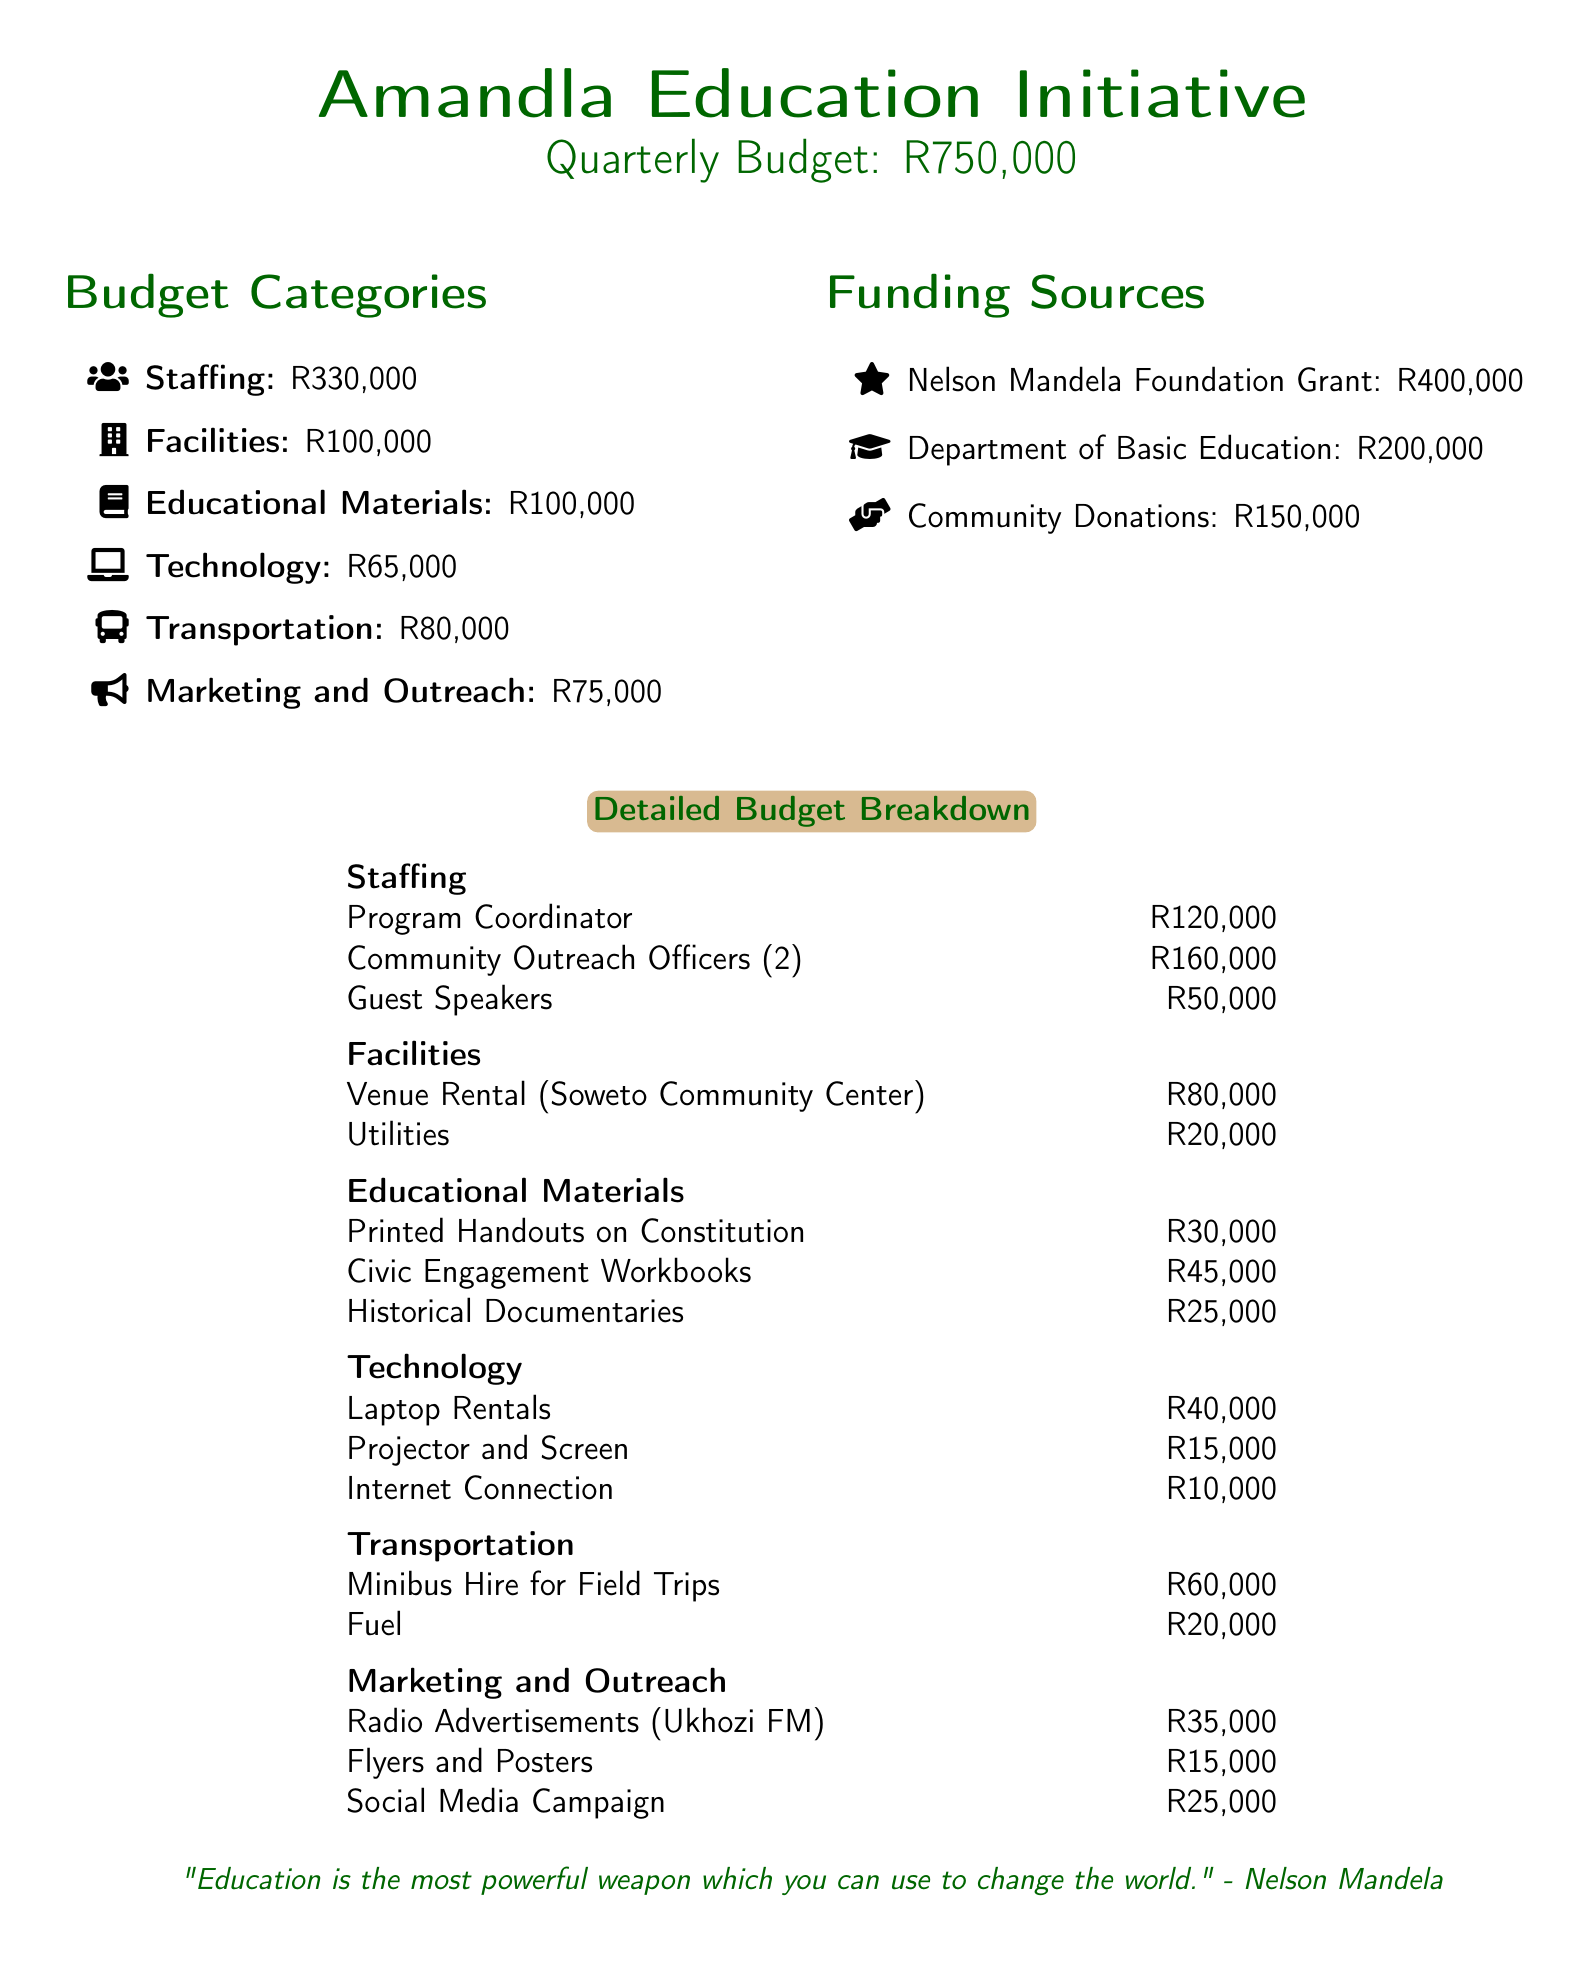What is the total budget for the Amandla Education Initiative? The total budget is explicitly stated in the document as R750,000.
Answer: R750,000 How much is allocated for staffing? The staffing budget category specifies R330,000 as the allocated amount.
Answer: R330,000 What is the budget for transportation? The budget for transportation is listed as R80,000.
Answer: R80,000 How much funding comes from the Nelson Mandela Foundation Grant? The document specifies that R400,000 comes from the Nelson Mandela Foundation Grant.
Answer: R400,000 What is the cost of community outreach officers? The detailed budget breakdown shows that the cost for the community outreach officers (2) is R160,000.
Answer: R160,000 What percentage of the total budget is allocated for educational materials? Educational materials are allocated R100,000 out of a total budget of R750,000, which is approximately 13.33%.
Answer: 13.33% How many guest speakers are budgeted for in the staffing section? The detailed budget breakdown indicates that the budget accommodates guest speakers costing R50,000, but the number is not specified.
Answer: Not specified What is the amount budgeted for marketing and outreach? The marketing and outreach budget is stated as R75,000.
Answer: R75,000 How much is allocated for internet connection in the technology section? The technology budget includes R10,000 specifically for internet connection.
Answer: R10,000 